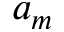<formula> <loc_0><loc_0><loc_500><loc_500>a _ { m }</formula> 